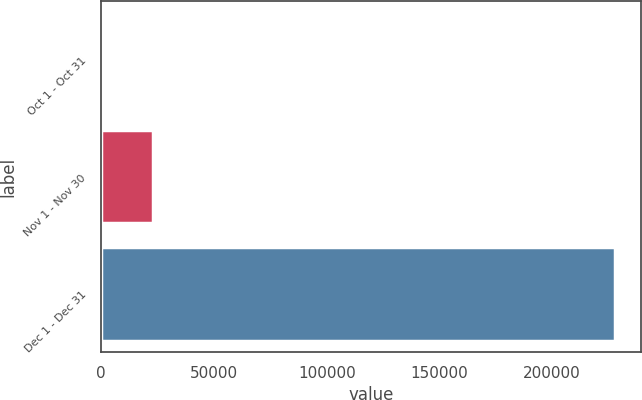<chart> <loc_0><loc_0><loc_500><loc_500><bar_chart><fcel>Oct 1 - Oct 31<fcel>Nov 1 - Nov 30<fcel>Dec 1 - Dec 31<nl><fcel>0.41<fcel>22800.4<fcel>228000<nl></chart> 